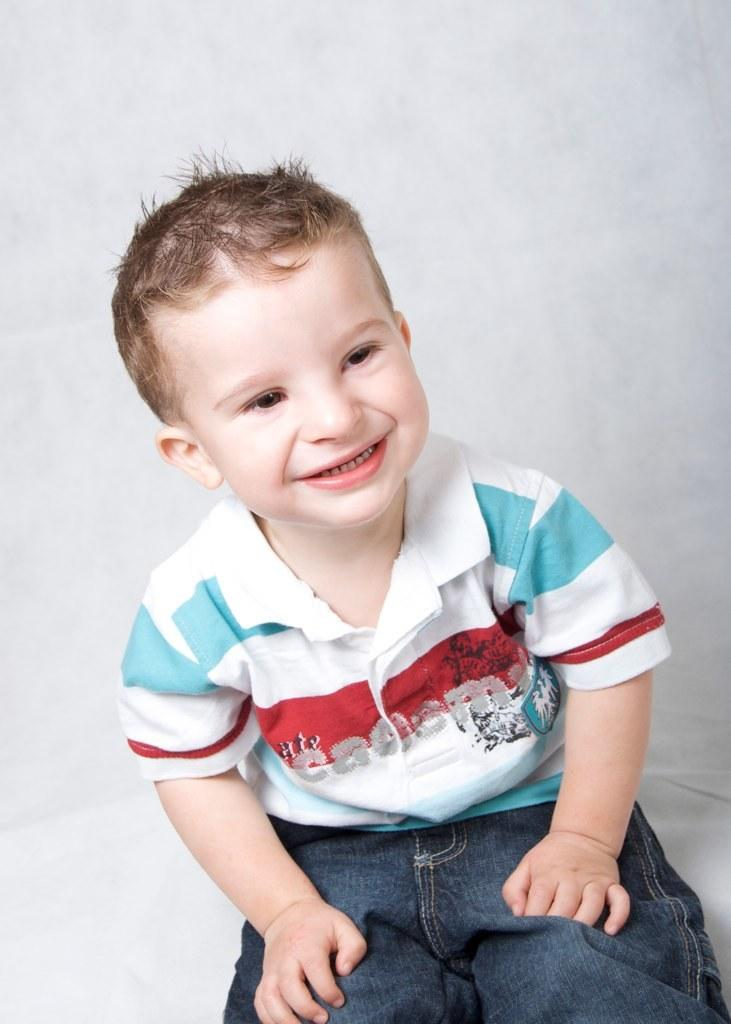What is the main subject of the image? There is a boy in the image. What is the boy's expression in the image? The boy is smiling in the image. What color is the crayon the boy is holding in the image? There is no crayon present in the image. What type of amusement park can be seen in the background of the image? There is no amusement park visible in the image; it only features a boy who is smiling. 